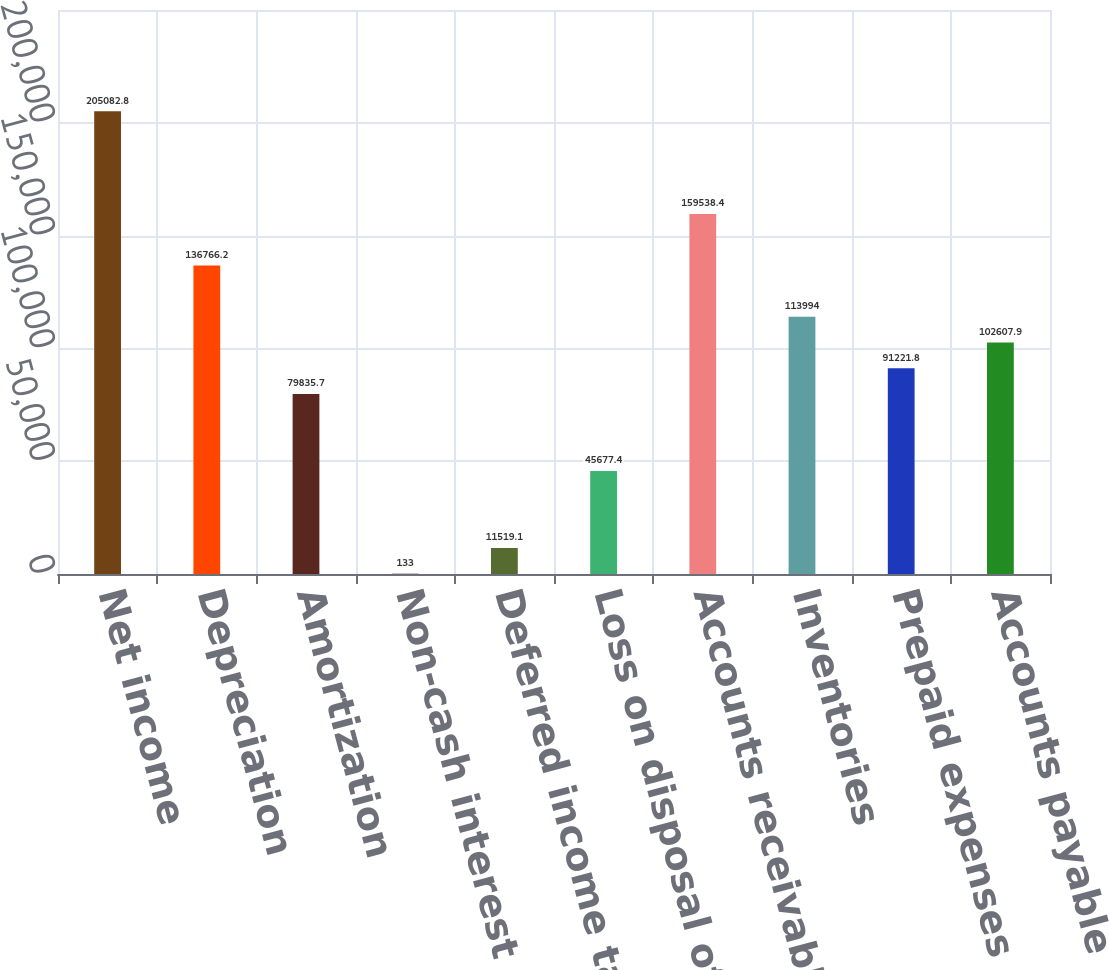<chart> <loc_0><loc_0><loc_500><loc_500><bar_chart><fcel>Net income<fcel>Depreciation<fcel>Amortization<fcel>Non-cash interest expense<fcel>Deferred income taxes<fcel>Loss on disposal of property<fcel>Accounts receivable<fcel>Inventories<fcel>Prepaid expenses and other<fcel>Accounts payable<nl><fcel>205083<fcel>136766<fcel>79835.7<fcel>133<fcel>11519.1<fcel>45677.4<fcel>159538<fcel>113994<fcel>91221.8<fcel>102608<nl></chart> 